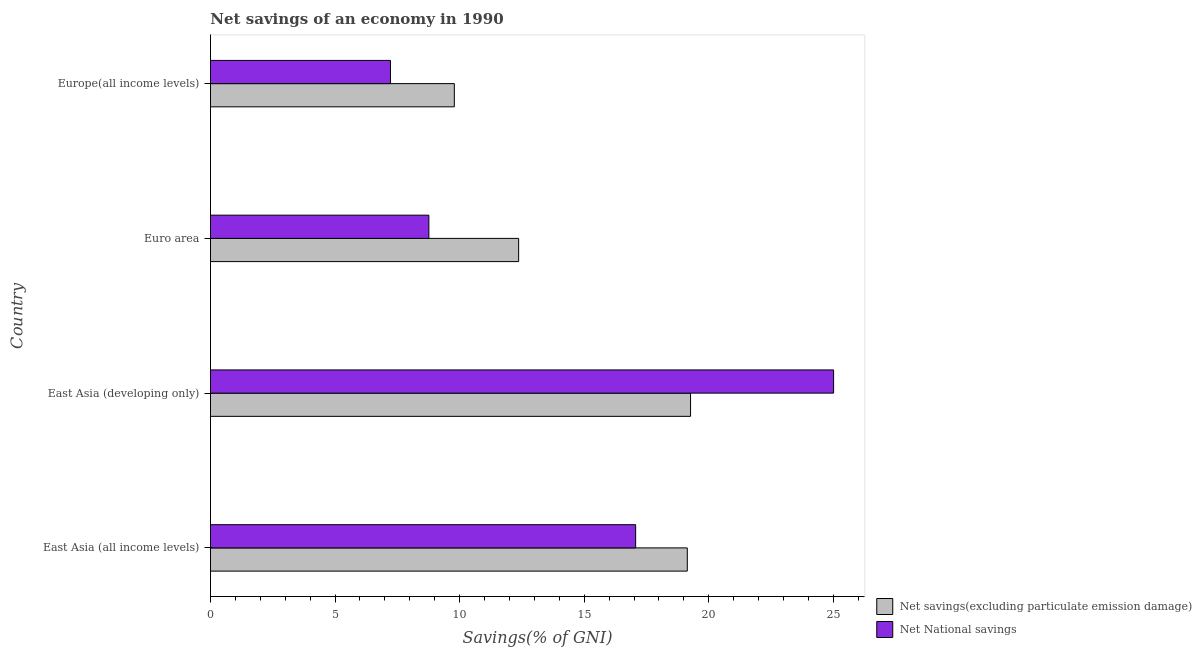Are the number of bars per tick equal to the number of legend labels?
Keep it short and to the point. Yes. Are the number of bars on each tick of the Y-axis equal?
Make the answer very short. Yes. What is the label of the 3rd group of bars from the top?
Give a very brief answer. East Asia (developing only). What is the net savings(excluding particulate emission damage) in East Asia (all income levels)?
Ensure brevity in your answer.  19.14. Across all countries, what is the maximum net savings(excluding particulate emission damage)?
Your answer should be compact. 19.27. Across all countries, what is the minimum net national savings?
Give a very brief answer. 7.23. In which country was the net national savings maximum?
Offer a terse response. East Asia (developing only). In which country was the net savings(excluding particulate emission damage) minimum?
Your answer should be compact. Europe(all income levels). What is the total net national savings in the graph?
Provide a succinct answer. 58.07. What is the difference between the net savings(excluding particulate emission damage) in Euro area and that in Europe(all income levels)?
Your response must be concise. 2.58. What is the difference between the net savings(excluding particulate emission damage) in Europe(all income levels) and the net national savings in East Asia (developing only)?
Provide a succinct answer. -15.22. What is the average net national savings per country?
Provide a succinct answer. 14.52. What is the difference between the net savings(excluding particulate emission damage) and net national savings in Euro area?
Your response must be concise. 3.6. In how many countries, is the net savings(excluding particulate emission damage) greater than 12 %?
Offer a very short reply. 3. What is the ratio of the net national savings in East Asia (developing only) to that in Euro area?
Give a very brief answer. 2.85. Is the difference between the net national savings in Euro area and Europe(all income levels) greater than the difference between the net savings(excluding particulate emission damage) in Euro area and Europe(all income levels)?
Provide a short and direct response. No. What is the difference between the highest and the second highest net national savings?
Give a very brief answer. 7.94. What is the difference between the highest and the lowest net savings(excluding particulate emission damage)?
Provide a succinct answer. 9.48. Is the sum of the net national savings in East Asia (developing only) and Europe(all income levels) greater than the maximum net savings(excluding particulate emission damage) across all countries?
Give a very brief answer. Yes. What does the 1st bar from the top in Euro area represents?
Make the answer very short. Net National savings. What does the 1st bar from the bottom in Europe(all income levels) represents?
Provide a short and direct response. Net savings(excluding particulate emission damage). Are all the bars in the graph horizontal?
Ensure brevity in your answer.  Yes. What is the difference between two consecutive major ticks on the X-axis?
Ensure brevity in your answer.  5. Does the graph contain grids?
Your answer should be compact. No. What is the title of the graph?
Provide a short and direct response. Net savings of an economy in 1990. What is the label or title of the X-axis?
Give a very brief answer. Savings(% of GNI). What is the label or title of the Y-axis?
Give a very brief answer. Country. What is the Savings(% of GNI) in Net savings(excluding particulate emission damage) in East Asia (all income levels)?
Your answer should be compact. 19.14. What is the Savings(% of GNI) in Net National savings in East Asia (all income levels)?
Provide a succinct answer. 17.07. What is the Savings(% of GNI) of Net savings(excluding particulate emission damage) in East Asia (developing only)?
Make the answer very short. 19.27. What is the Savings(% of GNI) in Net National savings in East Asia (developing only)?
Provide a short and direct response. 25.01. What is the Savings(% of GNI) in Net savings(excluding particulate emission damage) in Euro area?
Your answer should be very brief. 12.37. What is the Savings(% of GNI) of Net National savings in Euro area?
Provide a short and direct response. 8.77. What is the Savings(% of GNI) in Net savings(excluding particulate emission damage) in Europe(all income levels)?
Keep it short and to the point. 9.79. What is the Savings(% of GNI) of Net National savings in Europe(all income levels)?
Your answer should be very brief. 7.23. Across all countries, what is the maximum Savings(% of GNI) of Net savings(excluding particulate emission damage)?
Keep it short and to the point. 19.27. Across all countries, what is the maximum Savings(% of GNI) in Net National savings?
Provide a short and direct response. 25.01. Across all countries, what is the minimum Savings(% of GNI) of Net savings(excluding particulate emission damage)?
Offer a terse response. 9.79. Across all countries, what is the minimum Savings(% of GNI) in Net National savings?
Your answer should be very brief. 7.23. What is the total Savings(% of GNI) in Net savings(excluding particulate emission damage) in the graph?
Ensure brevity in your answer.  60.57. What is the total Savings(% of GNI) of Net National savings in the graph?
Ensure brevity in your answer.  58.07. What is the difference between the Savings(% of GNI) of Net savings(excluding particulate emission damage) in East Asia (all income levels) and that in East Asia (developing only)?
Your response must be concise. -0.13. What is the difference between the Savings(% of GNI) in Net National savings in East Asia (all income levels) and that in East Asia (developing only)?
Offer a very short reply. -7.94. What is the difference between the Savings(% of GNI) in Net savings(excluding particulate emission damage) in East Asia (all income levels) and that in Euro area?
Your answer should be compact. 6.77. What is the difference between the Savings(% of GNI) of Net National savings in East Asia (all income levels) and that in Euro area?
Give a very brief answer. 8.3. What is the difference between the Savings(% of GNI) in Net savings(excluding particulate emission damage) in East Asia (all income levels) and that in Europe(all income levels)?
Keep it short and to the point. 9.35. What is the difference between the Savings(% of GNI) of Net National savings in East Asia (all income levels) and that in Europe(all income levels)?
Offer a terse response. 9.84. What is the difference between the Savings(% of GNI) of Net savings(excluding particulate emission damage) in East Asia (developing only) and that in Euro area?
Your answer should be compact. 6.9. What is the difference between the Savings(% of GNI) in Net National savings in East Asia (developing only) and that in Euro area?
Your answer should be compact. 16.24. What is the difference between the Savings(% of GNI) of Net savings(excluding particulate emission damage) in East Asia (developing only) and that in Europe(all income levels)?
Your response must be concise. 9.48. What is the difference between the Savings(% of GNI) in Net National savings in East Asia (developing only) and that in Europe(all income levels)?
Keep it short and to the point. 17.79. What is the difference between the Savings(% of GNI) in Net savings(excluding particulate emission damage) in Euro area and that in Europe(all income levels)?
Your response must be concise. 2.58. What is the difference between the Savings(% of GNI) in Net National savings in Euro area and that in Europe(all income levels)?
Provide a short and direct response. 1.54. What is the difference between the Savings(% of GNI) in Net savings(excluding particulate emission damage) in East Asia (all income levels) and the Savings(% of GNI) in Net National savings in East Asia (developing only)?
Offer a very short reply. -5.87. What is the difference between the Savings(% of GNI) of Net savings(excluding particulate emission damage) in East Asia (all income levels) and the Savings(% of GNI) of Net National savings in Euro area?
Provide a succinct answer. 10.37. What is the difference between the Savings(% of GNI) of Net savings(excluding particulate emission damage) in East Asia (all income levels) and the Savings(% of GNI) of Net National savings in Europe(all income levels)?
Make the answer very short. 11.91. What is the difference between the Savings(% of GNI) in Net savings(excluding particulate emission damage) in East Asia (developing only) and the Savings(% of GNI) in Net National savings in Euro area?
Your answer should be very brief. 10.5. What is the difference between the Savings(% of GNI) in Net savings(excluding particulate emission damage) in East Asia (developing only) and the Savings(% of GNI) in Net National savings in Europe(all income levels)?
Provide a succinct answer. 12.04. What is the difference between the Savings(% of GNI) of Net savings(excluding particulate emission damage) in Euro area and the Savings(% of GNI) of Net National savings in Europe(all income levels)?
Make the answer very short. 5.14. What is the average Savings(% of GNI) in Net savings(excluding particulate emission damage) per country?
Your response must be concise. 15.14. What is the average Savings(% of GNI) of Net National savings per country?
Make the answer very short. 14.52. What is the difference between the Savings(% of GNI) in Net savings(excluding particulate emission damage) and Savings(% of GNI) in Net National savings in East Asia (all income levels)?
Provide a short and direct response. 2.07. What is the difference between the Savings(% of GNI) of Net savings(excluding particulate emission damage) and Savings(% of GNI) of Net National savings in East Asia (developing only)?
Give a very brief answer. -5.74. What is the difference between the Savings(% of GNI) in Net savings(excluding particulate emission damage) and Savings(% of GNI) in Net National savings in Euro area?
Offer a very short reply. 3.6. What is the difference between the Savings(% of GNI) of Net savings(excluding particulate emission damage) and Savings(% of GNI) of Net National savings in Europe(all income levels)?
Ensure brevity in your answer.  2.56. What is the ratio of the Savings(% of GNI) in Net savings(excluding particulate emission damage) in East Asia (all income levels) to that in East Asia (developing only)?
Give a very brief answer. 0.99. What is the ratio of the Savings(% of GNI) in Net National savings in East Asia (all income levels) to that in East Asia (developing only)?
Make the answer very short. 0.68. What is the ratio of the Savings(% of GNI) of Net savings(excluding particulate emission damage) in East Asia (all income levels) to that in Euro area?
Your response must be concise. 1.55. What is the ratio of the Savings(% of GNI) of Net National savings in East Asia (all income levels) to that in Euro area?
Give a very brief answer. 1.95. What is the ratio of the Savings(% of GNI) in Net savings(excluding particulate emission damage) in East Asia (all income levels) to that in Europe(all income levels)?
Your answer should be compact. 1.96. What is the ratio of the Savings(% of GNI) in Net National savings in East Asia (all income levels) to that in Europe(all income levels)?
Your response must be concise. 2.36. What is the ratio of the Savings(% of GNI) in Net savings(excluding particulate emission damage) in East Asia (developing only) to that in Euro area?
Give a very brief answer. 1.56. What is the ratio of the Savings(% of GNI) in Net National savings in East Asia (developing only) to that in Euro area?
Offer a very short reply. 2.85. What is the ratio of the Savings(% of GNI) of Net savings(excluding particulate emission damage) in East Asia (developing only) to that in Europe(all income levels)?
Give a very brief answer. 1.97. What is the ratio of the Savings(% of GNI) in Net National savings in East Asia (developing only) to that in Europe(all income levels)?
Provide a succinct answer. 3.46. What is the ratio of the Savings(% of GNI) in Net savings(excluding particulate emission damage) in Euro area to that in Europe(all income levels)?
Your answer should be compact. 1.26. What is the ratio of the Savings(% of GNI) in Net National savings in Euro area to that in Europe(all income levels)?
Ensure brevity in your answer.  1.21. What is the difference between the highest and the second highest Savings(% of GNI) in Net savings(excluding particulate emission damage)?
Give a very brief answer. 0.13. What is the difference between the highest and the second highest Savings(% of GNI) in Net National savings?
Your answer should be compact. 7.94. What is the difference between the highest and the lowest Savings(% of GNI) in Net savings(excluding particulate emission damage)?
Your response must be concise. 9.48. What is the difference between the highest and the lowest Savings(% of GNI) in Net National savings?
Make the answer very short. 17.79. 